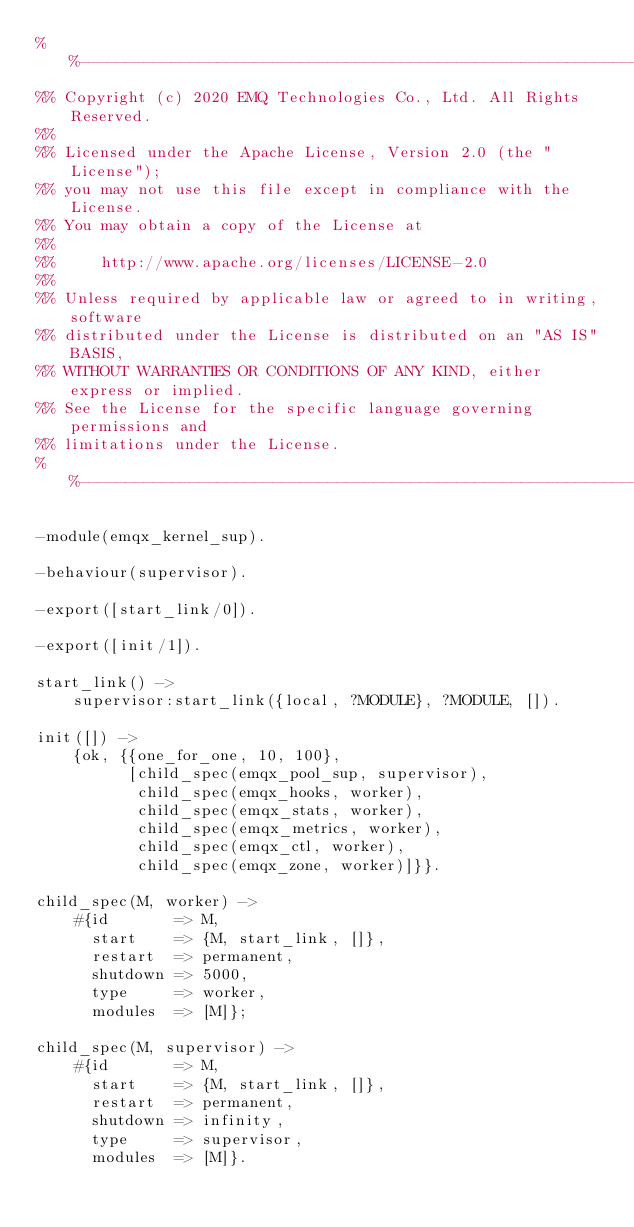<code> <loc_0><loc_0><loc_500><loc_500><_Erlang_>%%--------------------------------------------------------------------
%% Copyright (c) 2020 EMQ Technologies Co., Ltd. All Rights Reserved.
%%
%% Licensed under the Apache License, Version 2.0 (the "License");
%% you may not use this file except in compliance with the License.
%% You may obtain a copy of the License at
%%
%%     http://www.apache.org/licenses/LICENSE-2.0
%%
%% Unless required by applicable law or agreed to in writing, software
%% distributed under the License is distributed on an "AS IS" BASIS,
%% WITHOUT WARRANTIES OR CONDITIONS OF ANY KIND, either express or implied.
%% See the License for the specific language governing permissions and
%% limitations under the License.
%%--------------------------------------------------------------------

-module(emqx_kernel_sup).

-behaviour(supervisor).

-export([start_link/0]).

-export([init/1]).

start_link() ->
    supervisor:start_link({local, ?MODULE}, ?MODULE, []).

init([]) ->
    {ok, {{one_for_one, 10, 100},
          [child_spec(emqx_pool_sup, supervisor),
           child_spec(emqx_hooks, worker),
           child_spec(emqx_stats, worker),
           child_spec(emqx_metrics, worker),
           child_spec(emqx_ctl, worker),
           child_spec(emqx_zone, worker)]}}.

child_spec(M, worker) ->
    #{id       => M,
      start    => {M, start_link, []},
      restart  => permanent,
      shutdown => 5000,
      type     => worker,
      modules  => [M]};

child_spec(M, supervisor) ->
    #{id       => M,
      start    => {M, start_link, []},
      restart  => permanent,
      shutdown => infinity,
      type     => supervisor,
      modules  => [M]}.


</code> 